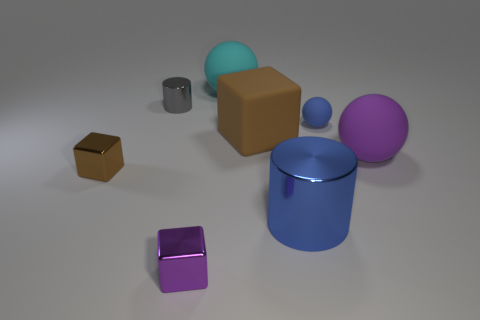Is the color of the large cylinder the same as the small sphere?
Your answer should be very brief. Yes. There is a large ball behind the small gray cylinder; what is its color?
Provide a succinct answer. Cyan. There is a rubber block; is its size the same as the blue thing that is behind the large blue thing?
Make the answer very short. No. What is the size of the matte thing that is both on the left side of the large cylinder and in front of the cyan thing?
Your response must be concise. Large. Is there a small brown block made of the same material as the big blue cylinder?
Your response must be concise. Yes. What shape is the blue metallic object?
Offer a terse response. Cylinder. Is the purple matte thing the same size as the cyan rubber sphere?
Provide a short and direct response. Yes. How many other things are there of the same shape as the big blue metal object?
Give a very brief answer. 1. What is the shape of the big matte object behind the gray shiny thing?
Offer a terse response. Sphere. Do the brown thing on the right side of the cyan matte ball and the purple object that is to the left of the purple matte object have the same shape?
Provide a succinct answer. Yes. 